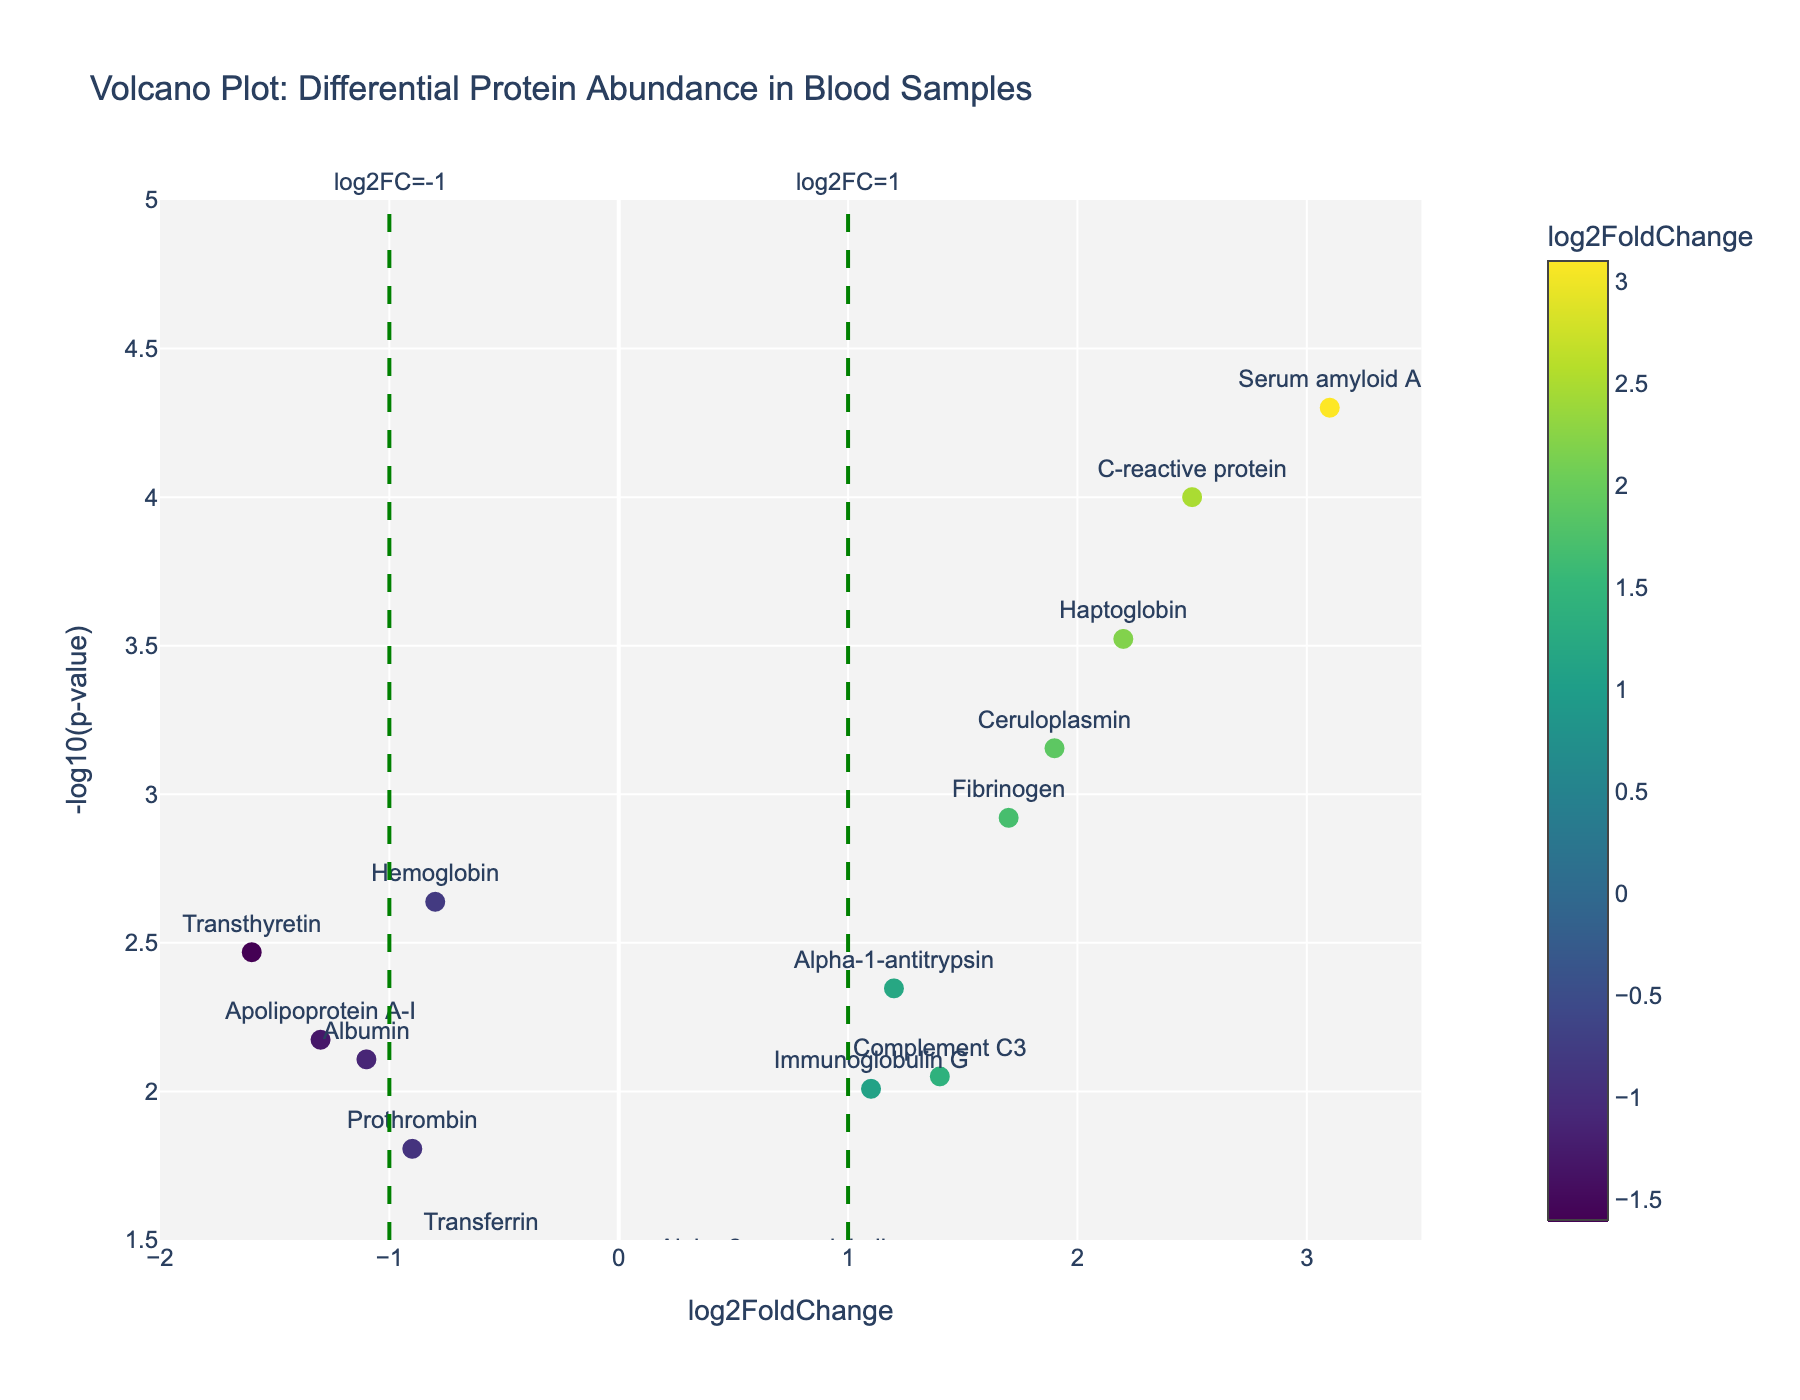Is there any protein with a log2FoldChange greater than 2? To determine this, look at the x-axis representing log2FoldChange and identify any point with a value greater than 2. In the plot, C-reactive protein and Serum amyloid A both have log2FoldChange values greater than 2.
Answer: Yes Which protein has the smallest p-value? To find the protein with the smallest p-value, look at the y-axis representing -log10(p-value) and identify the point with the highest value since a smaller p-value translates to a higher -log10(p-value). Serum amyloid A has the highest -log10(p-value).
Answer: Serum amyloid A What is the log2FoldChange for Albumin? Locate the point labeled 'Albumin' and read its x-coordinate which represents the log2FoldChange. Albumin has a log2FoldChange of -1.1.
Answer: -1.1 How many proteins have a p-value less than 0.01? Identify the horizontal line representing p-value = 0.01 (or -log10(p-value) = 2) and count the number of points above this line. In the plot, Hemoglobin, Alpha-1-antitrypsin, C-reactive protein, Serum amyloid A, Fibrinogen, Haptoglobin, Ceruloplasmin, and Transthyretin—8 proteins in total—are above this line.
Answer: 8 Among the proteins with log2FoldChange greater than 0, which one has the lowest p-value? Filter the points on the right side of the plot (log2FoldChange > 0), then identify the one with the highest value on the y-axis (-log10(p-value)). Serum amyloid A has the highest -log10(p-value) among them.
Answer: Serum amyloid A What is the range of the y-axis? To determine the range, look at the minimum and maximum values on the y-axis, which represents -log10(p-value). The y-axis ranges from approximately 1.5 to 5.
Answer: 1.5 to 5 How many proteins have negative log2FoldChange values but significant p-values (p < 0.05)? Find the vertical dashed line at log2FoldChange = 0 and the horizontal dashed line at p-value = 0.05 (or -log10(p-value) = 1.3), then count the points in the left region (negative log2FoldChange) and above the horizontal line. Hemoglobin, Albumin, Prothrombin, Apolipoprotein A-I, and Transthyretin—5 proteins in total—meet these criteria.
Answer: 5 Which proteins have a log2FoldChange between -1 and 1? Identify the points in the vertical region between -1 and 1 on the x-axis. Hemoglobin, Alpha-2-macroglobulin, Complement C3, Transferrin, Prothrombin, Immunoglobulin G, and Alpha-2-macroglobulin fall within this range.
Answer: Hemoglobin, Alpha-2-macroglobulin, Complement C3, Transferrin, Prothrombin, Immunoglobulin G What is the title of the plot? Look at the top of the plot where the title is located. The title is 'Volcano Plot: Differential Protein Abundance in Blood Samples'.
Answer: Volcano Plot: Differential Protein Abundance in Blood Samples 